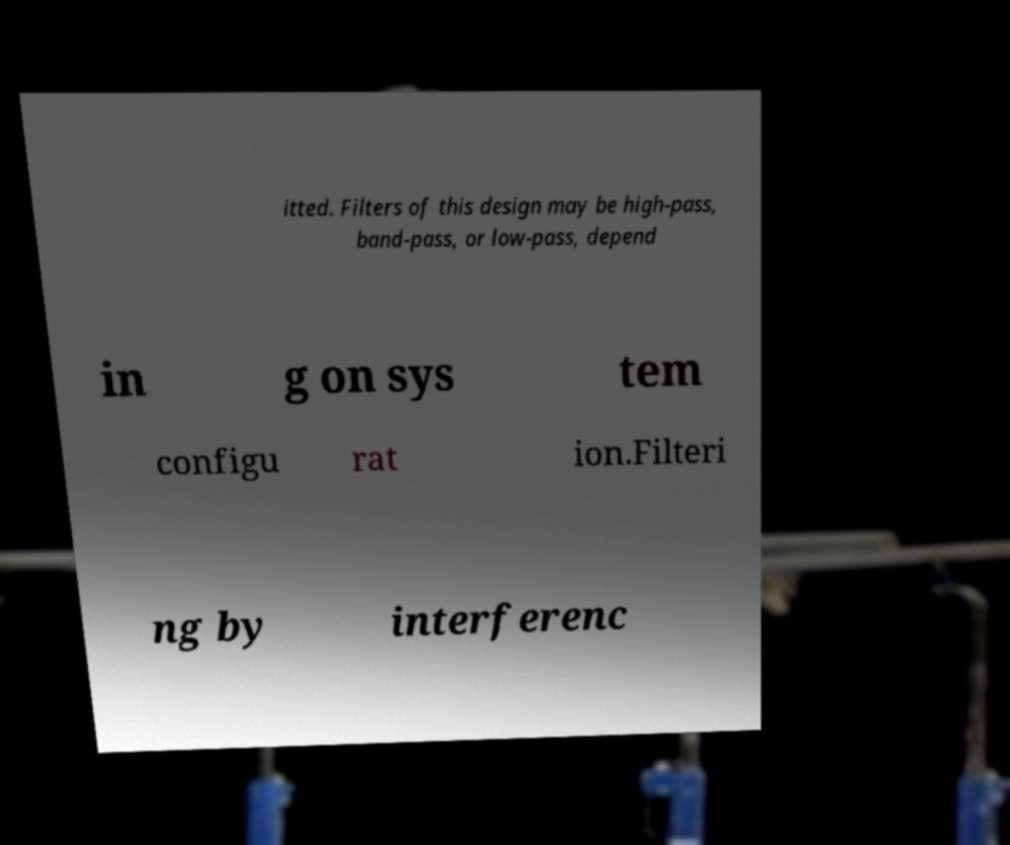For documentation purposes, I need the text within this image transcribed. Could you provide that? itted. Filters of this design may be high-pass, band-pass, or low-pass, depend in g on sys tem configu rat ion.Filteri ng by interferenc 